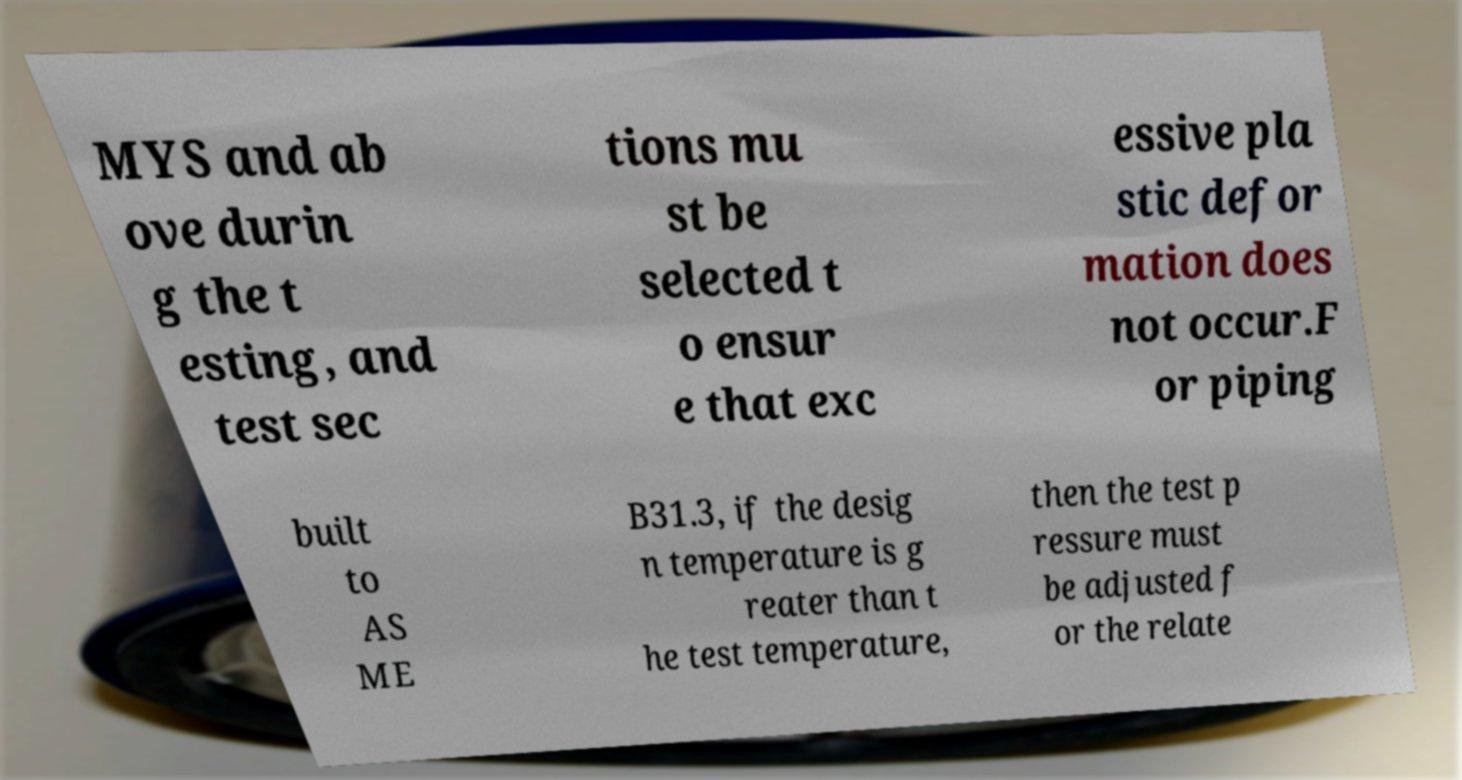Can you read and provide the text displayed in the image?This photo seems to have some interesting text. Can you extract and type it out for me? MYS and ab ove durin g the t esting, and test sec tions mu st be selected t o ensur e that exc essive pla stic defor mation does not occur.F or piping built to AS ME B31.3, if the desig n temperature is g reater than t he test temperature, then the test p ressure must be adjusted f or the relate 